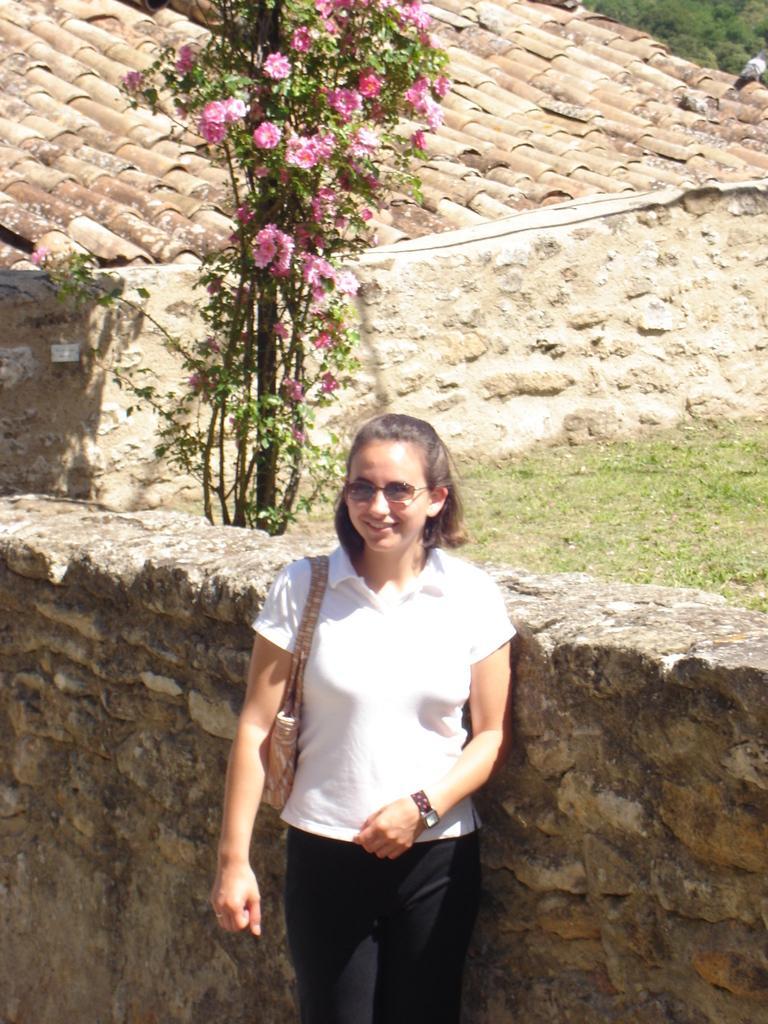Describe this image in one or two sentences. In this picture there is a woman standing and smiling. At the back there is a wall and there are pink color flowers on the plant. There is a pigeon sitting on the building. There are roof tiles on the top of the building. There are trees behind the building. At the bottom there is grass. 